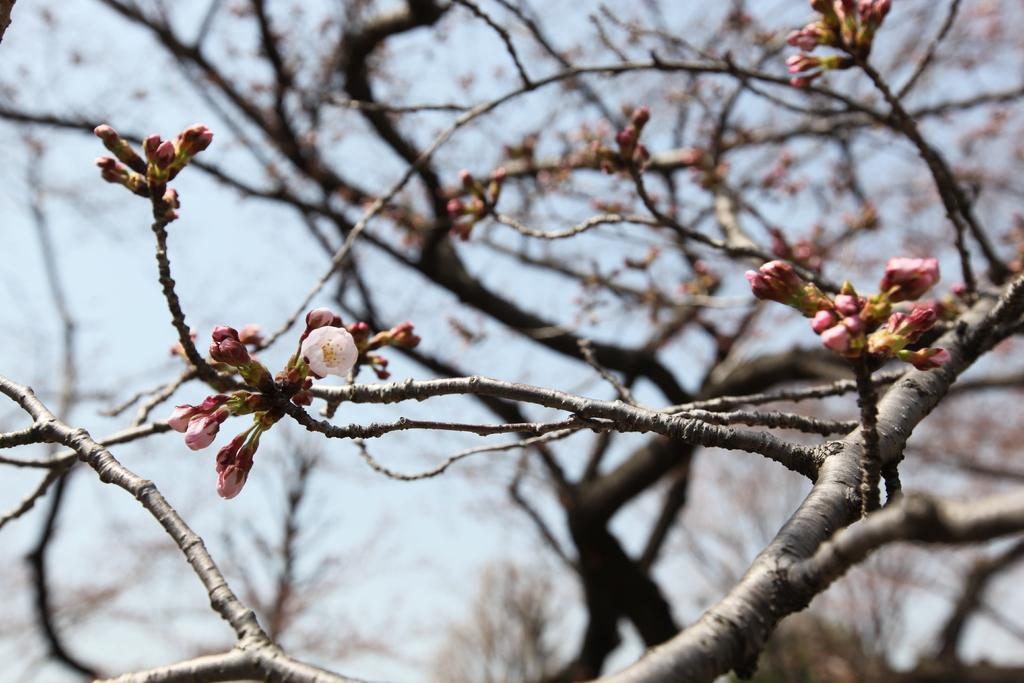What type of plant is featured in the image? There is a tree with buds in the image. Can you describe the flower in the image? There is a flower on the left side of the image. What can be seen in the background of the image? The sky is visible in the background of the image. How many trees are visible at the bottom of the image? There are multiple trees at the bottom of the image. What decision did the committee make in the image? There is no mention of a committee or any decision-making process in the image. Why is the boot crying in the image? There is no boot or any crying object in the image. 